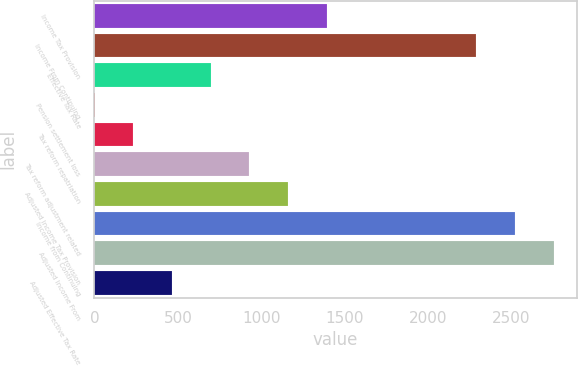Convert chart to OTSL. <chart><loc_0><loc_0><loc_500><loc_500><bar_chart><fcel>Income Tax Provision<fcel>Income From Continuing<fcel>Effective Tax Rate<fcel>Pension settlement loss<fcel>Tax reform repatriation<fcel>Tax reform adjustment related<fcel>Adjusted Income Tax Provision<fcel>Income from Continuing<fcel>Adjusted Income From<fcel>Adjusted Effective Tax Rate<nl><fcel>1392.42<fcel>2289.5<fcel>696.81<fcel>1.2<fcel>233.07<fcel>928.68<fcel>1160.55<fcel>2521.37<fcel>2753.24<fcel>464.94<nl></chart> 